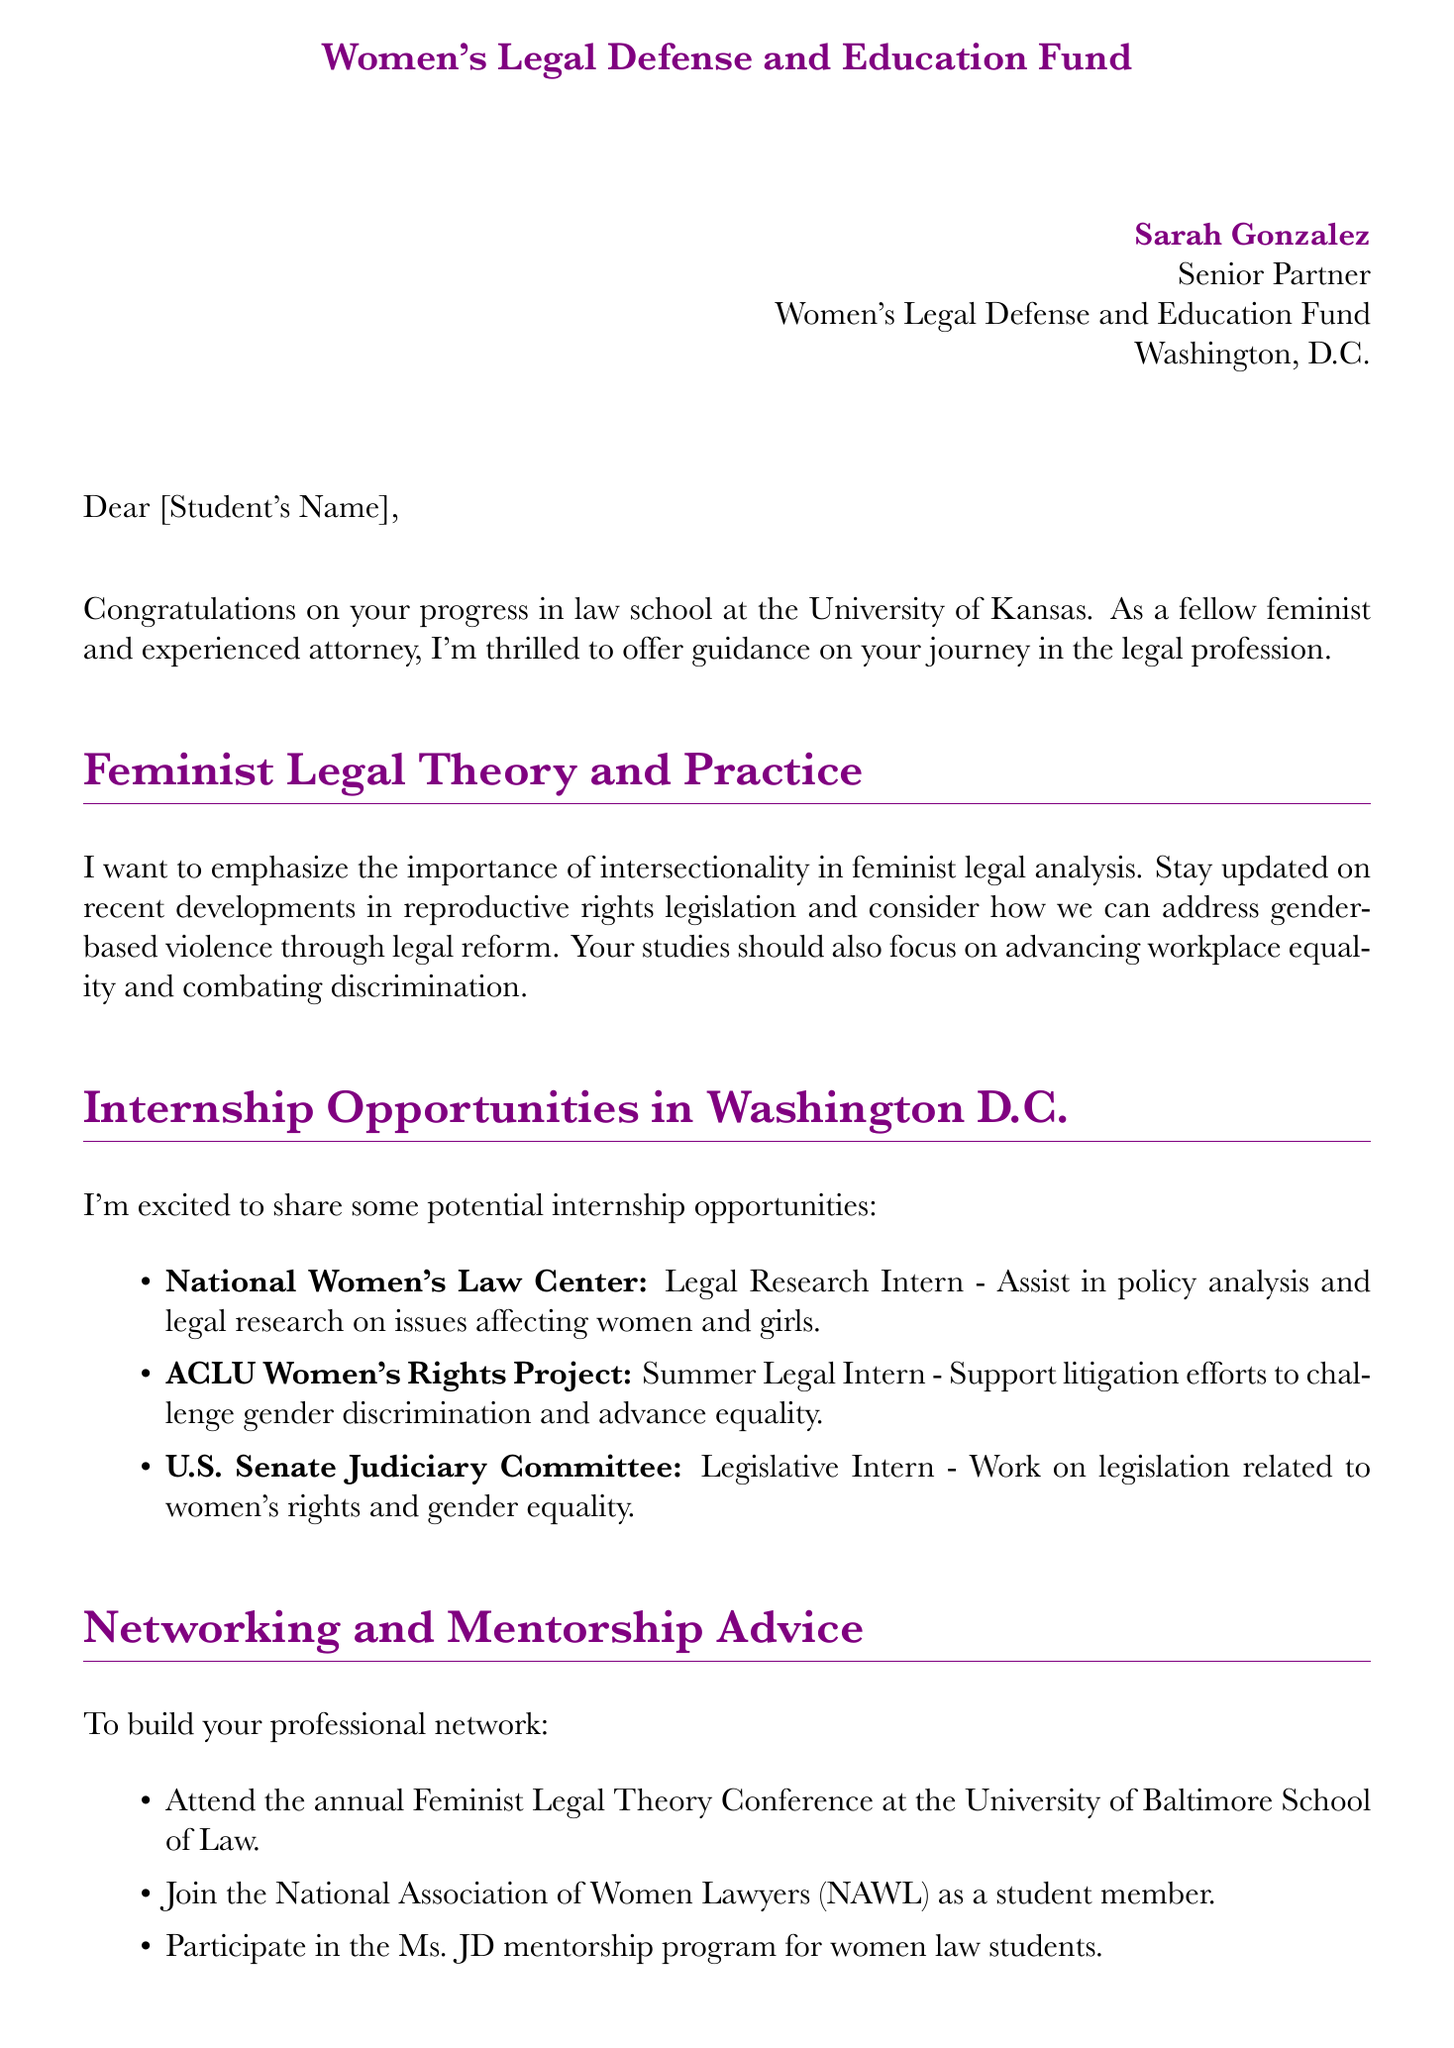What is the name of the mentor? The mentor's name is stated at the beginning of the letter.
Answer: Sarah Gonzalez What position does Sarah Gonzalez hold? This information is provided in the introduction section of the letter.
Answer: Senior Partner What organization is Sarah Gonzalez associated with? The letter specifies the organization where Sarah works.
Answer: Women's Legal Defense and Education Fund Which city is the organization located in? The location of the organization is mentioned in the contact details.
Answer: Washington, D.C What type of intern position is offered at the National Women's Law Center? This can be found in the internship opportunities section of the letter.
Answer: Legal Research Intern Which conference should the student attend for networking? The letter includes a suggestion for networking opportunities.
Answer: Feminist Legal Theory Conference What is one way to balance activism with a legal career? The letter discusses strategies for balancing these two aspects in a career.
Answer: Engage in pro bono work What resource is mentioned that focuses on feminist perspectives of Supreme Court cases? The letter lists relevant resources and one specifically fits this description.
Answer: Feminist Judgments: Rewritten Opinions of the United States Supreme Court What type of work might a Legislative Intern do at the U.S. Senate Judiciary Committee? The letter outlines the responsibilities associated with this internship position.
Answer: Work on legislation related to women's rights and gender equality How does Sarah Gonzalez sign off the letter? The closing of a letter usually contains a sign-off phrase.
Answer: Warmest regards 